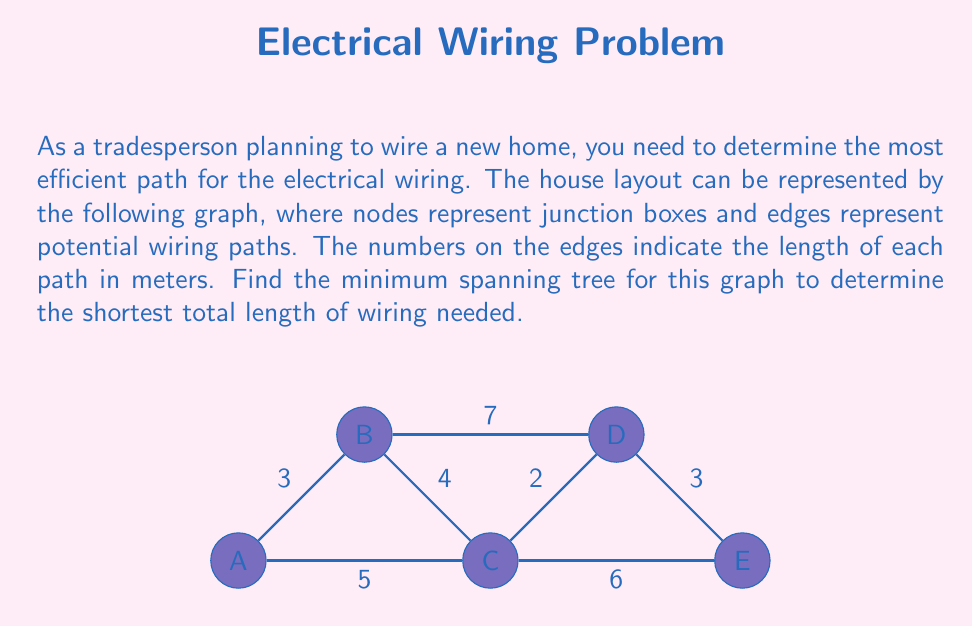Can you answer this question? To find the minimum spanning tree (MST) for this graph, we can use Kruskal's algorithm:

1) Sort all edges by weight (length) in ascending order:
   CD (2), AB (3), DE (3), BC (4), AC (5), CE (6), BD (7)

2) Start with an empty MST and add edges one by one:
   - Add CD (2)
   - Add AB (3)
   - Add DE (3)
   - Add BC (4)
   
At this point, we have connected all nodes with 4 edges, forming a tree. We stop here as adding any more edges would create a cycle.

3) Calculate the total length of the MST:
   $L_{total} = 2 + 3 + 3 + 4 = 12$ meters

The minimum spanning tree consists of edges CD, AB, DE, and BC, with a total length of 12 meters.

This solution provides the most efficient wiring path, minimizing material costs and potentially reducing voltage drop across the system.
Answer: 12 meters 